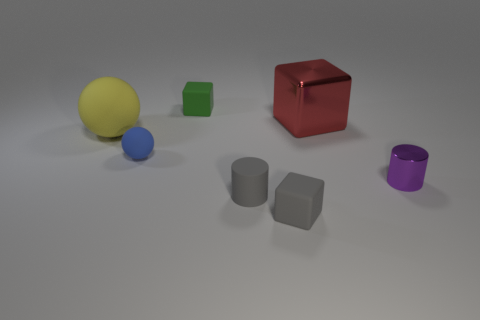Add 2 small blue objects. How many objects exist? 9 Subtract all cubes. How many objects are left? 4 Add 5 gray matte cylinders. How many gray matte cylinders exist? 6 Subtract 0 yellow blocks. How many objects are left? 7 Subtract all small gray spheres. Subtract all tiny gray matte blocks. How many objects are left? 6 Add 1 gray blocks. How many gray blocks are left? 2 